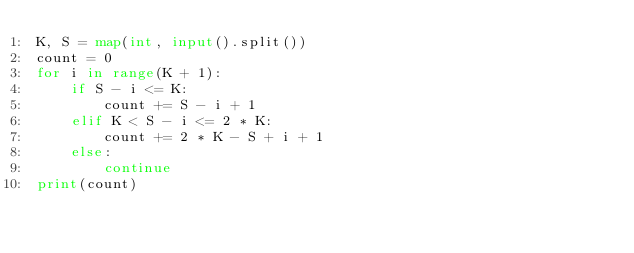<code> <loc_0><loc_0><loc_500><loc_500><_Python_>K, S = map(int, input().split())
count = 0
for i in range(K + 1):
    if S - i <= K:
        count += S - i + 1
    elif K < S - i <= 2 * K:
        count += 2 * K - S + i + 1
    else:
        continue
print(count)</code> 